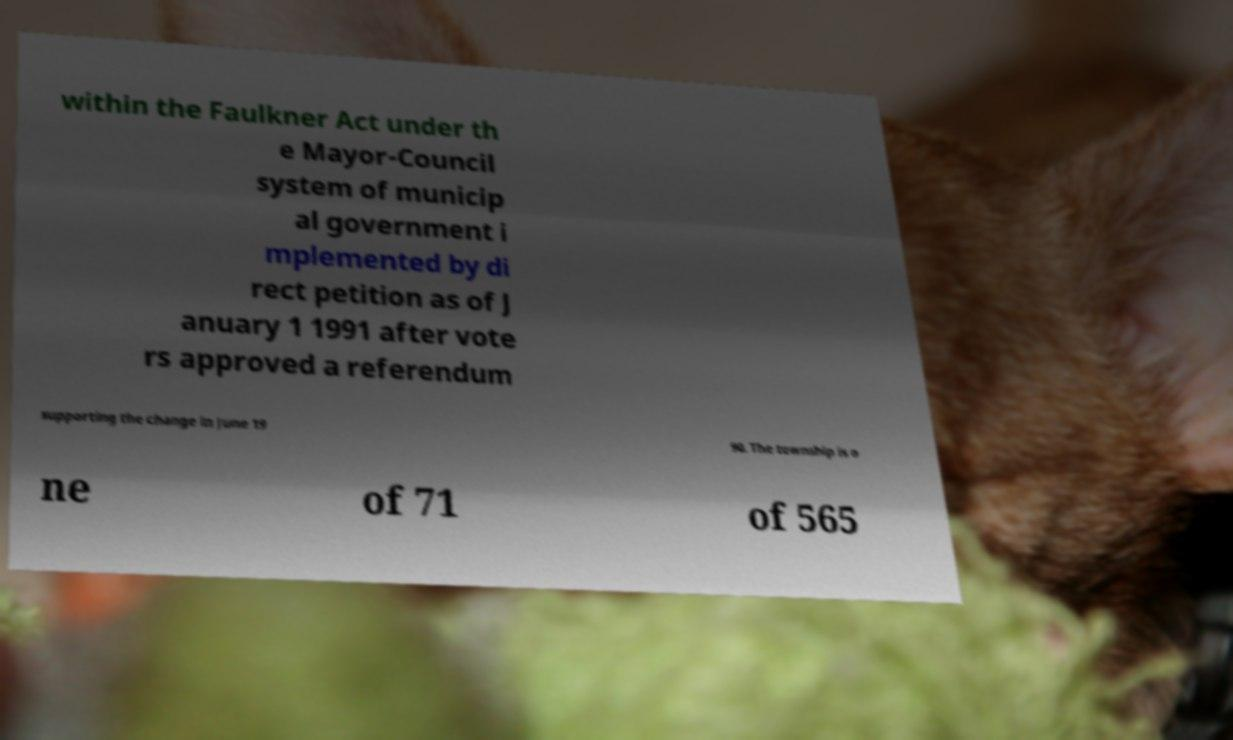For documentation purposes, I need the text within this image transcribed. Could you provide that? within the Faulkner Act under th e Mayor-Council system of municip al government i mplemented by di rect petition as of J anuary 1 1991 after vote rs approved a referendum supporting the change in June 19 90. The township is o ne of 71 of 565 